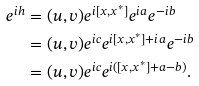<formula> <loc_0><loc_0><loc_500><loc_500>e ^ { i h } & = ( u , v ) e ^ { i [ x , x ^ { * } ] } e ^ { i a } e ^ { - i b } \\ & = ( u , v ) e ^ { i c } e ^ { i [ x , x ^ { * } ] + i a } e ^ { - i b } \\ & = ( u , v ) e ^ { i c } e ^ { i ( [ x , x ^ { * } ] + a - b ) } .</formula> 